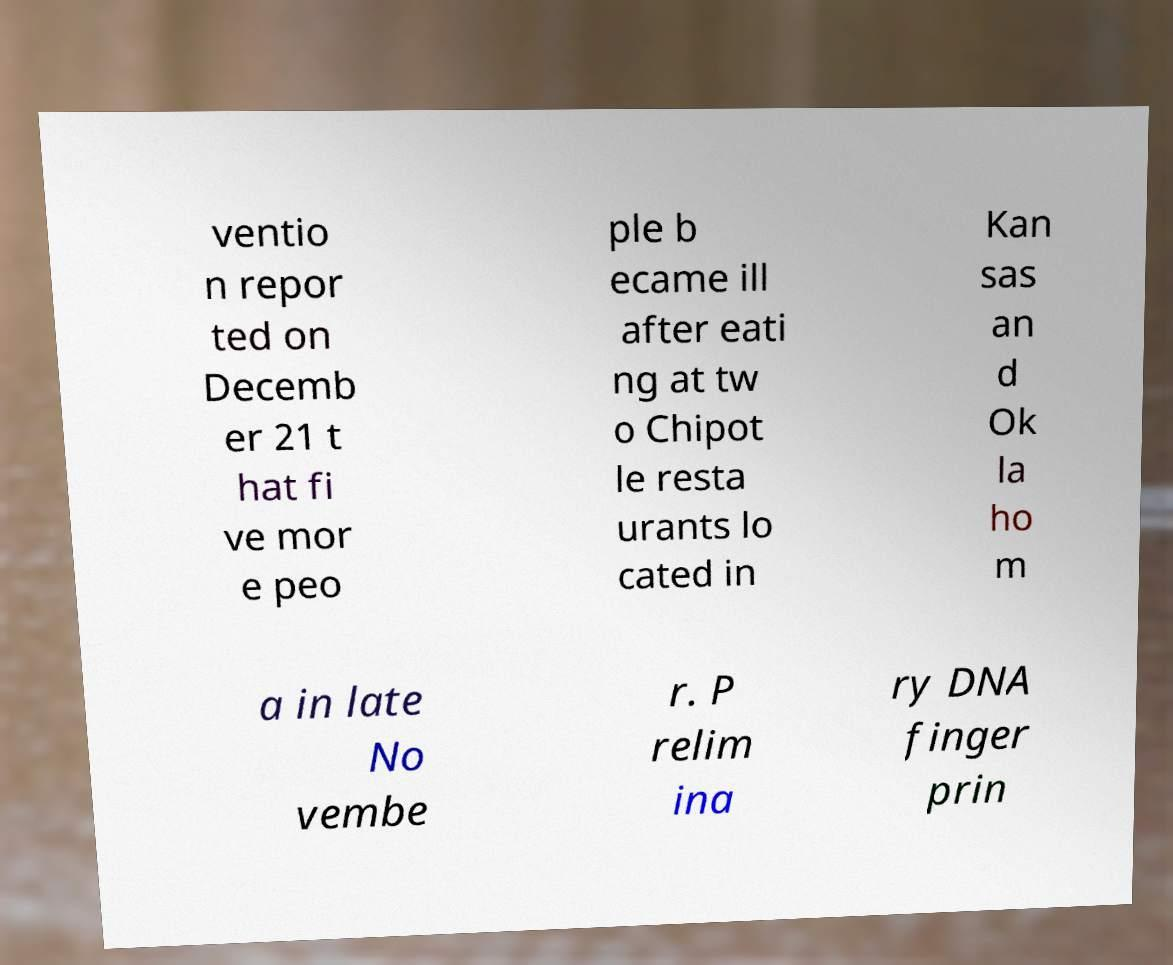Please read and relay the text visible in this image. What does it say? ventio n repor ted on Decemb er 21 t hat fi ve mor e peo ple b ecame ill after eati ng at tw o Chipot le resta urants lo cated in Kan sas an d Ok la ho m a in late No vembe r. P relim ina ry DNA finger prin 